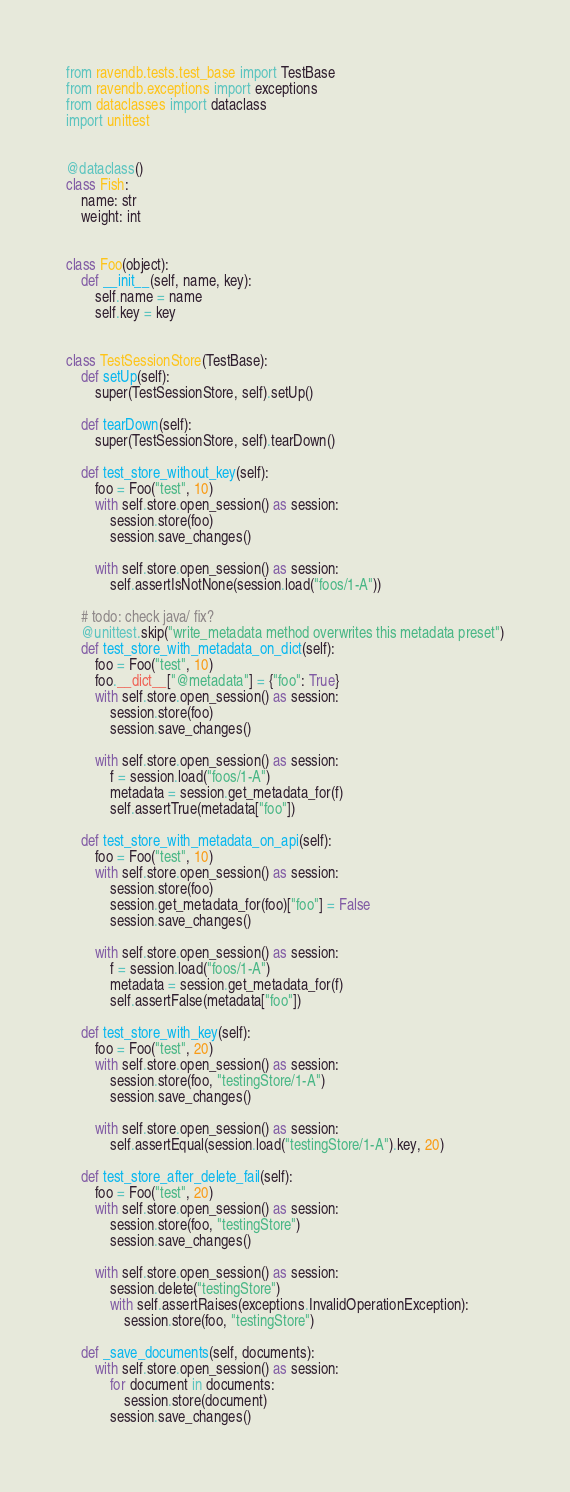Convert code to text. <code><loc_0><loc_0><loc_500><loc_500><_Python_>from ravendb.tests.test_base import TestBase
from ravendb.exceptions import exceptions
from dataclasses import dataclass
import unittest


@dataclass()
class Fish:
    name: str
    weight: int


class Foo(object):
    def __init__(self, name, key):
        self.name = name
        self.key = key


class TestSessionStore(TestBase):
    def setUp(self):
        super(TestSessionStore, self).setUp()

    def tearDown(self):
        super(TestSessionStore, self).tearDown()

    def test_store_without_key(self):
        foo = Foo("test", 10)
        with self.store.open_session() as session:
            session.store(foo)
            session.save_changes()

        with self.store.open_session() as session:
            self.assertIsNotNone(session.load("foos/1-A"))

    # todo: check java/ fix?
    @unittest.skip("write_metadata method overwrites this metadata preset")
    def test_store_with_metadata_on_dict(self):
        foo = Foo("test", 10)
        foo.__dict__["@metadata"] = {"foo": True}
        with self.store.open_session() as session:
            session.store(foo)
            session.save_changes()

        with self.store.open_session() as session:
            f = session.load("foos/1-A")
            metadata = session.get_metadata_for(f)
            self.assertTrue(metadata["foo"])

    def test_store_with_metadata_on_api(self):
        foo = Foo("test", 10)
        with self.store.open_session() as session:
            session.store(foo)
            session.get_metadata_for(foo)["foo"] = False
            session.save_changes()

        with self.store.open_session() as session:
            f = session.load("foos/1-A")
            metadata = session.get_metadata_for(f)
            self.assertFalse(metadata["foo"])

    def test_store_with_key(self):
        foo = Foo("test", 20)
        with self.store.open_session() as session:
            session.store(foo, "testingStore/1-A")
            session.save_changes()

        with self.store.open_session() as session:
            self.assertEqual(session.load("testingStore/1-A").key, 20)

    def test_store_after_delete_fail(self):
        foo = Foo("test", 20)
        with self.store.open_session() as session:
            session.store(foo, "testingStore")
            session.save_changes()

        with self.store.open_session() as session:
            session.delete("testingStore")
            with self.assertRaises(exceptions.InvalidOperationException):
                session.store(foo, "testingStore")

    def _save_documents(self, documents):
        with self.store.open_session() as session:
            for document in documents:
                session.store(document)
            session.save_changes()
</code> 